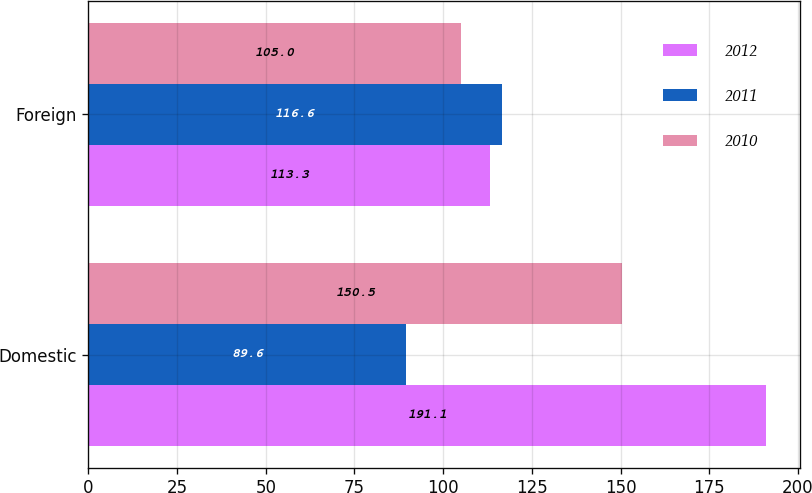Convert chart to OTSL. <chart><loc_0><loc_0><loc_500><loc_500><stacked_bar_chart><ecel><fcel>Domestic<fcel>Foreign<nl><fcel>2012<fcel>191.1<fcel>113.3<nl><fcel>2011<fcel>89.6<fcel>116.6<nl><fcel>2010<fcel>150.5<fcel>105<nl></chart> 